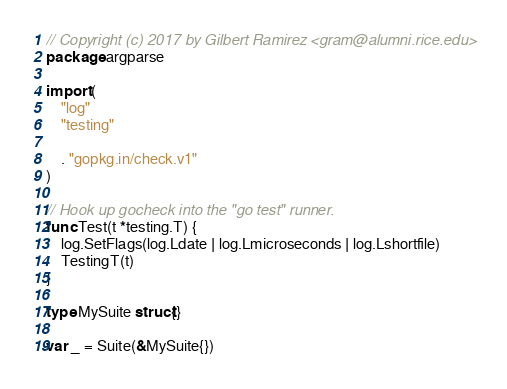Convert code to text. <code><loc_0><loc_0><loc_500><loc_500><_Go_>// Copyright (c) 2017 by Gilbert Ramirez <gram@alumni.rice.edu>
package argparse

import (
	"log"
	"testing"

	. "gopkg.in/check.v1"
)

// Hook up gocheck into the "go test" runner.
func Test(t *testing.T) {
	log.SetFlags(log.Ldate | log.Lmicroseconds | log.Lshortfile)
	TestingT(t)
}

type MySuite struct{}

var _ = Suite(&MySuite{})
</code> 